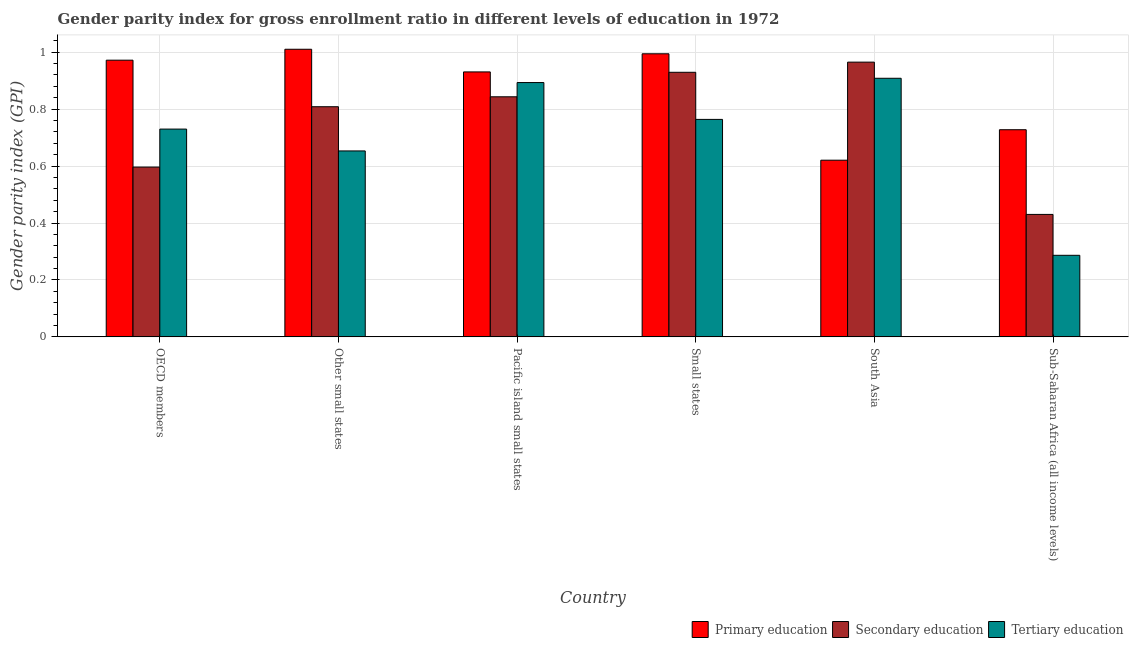Are the number of bars per tick equal to the number of legend labels?
Ensure brevity in your answer.  Yes. How many bars are there on the 3rd tick from the left?
Provide a succinct answer. 3. How many bars are there on the 6th tick from the right?
Offer a very short reply. 3. What is the label of the 1st group of bars from the left?
Offer a terse response. OECD members. What is the gender parity index in tertiary education in Other small states?
Provide a succinct answer. 0.65. Across all countries, what is the maximum gender parity index in tertiary education?
Your response must be concise. 0.91. Across all countries, what is the minimum gender parity index in secondary education?
Give a very brief answer. 0.43. In which country was the gender parity index in secondary education maximum?
Offer a very short reply. South Asia. What is the total gender parity index in secondary education in the graph?
Offer a very short reply. 4.57. What is the difference between the gender parity index in secondary education in OECD members and that in Other small states?
Give a very brief answer. -0.21. What is the difference between the gender parity index in tertiary education in Small states and the gender parity index in secondary education in Sub-Saharan Africa (all income levels)?
Your answer should be compact. 0.33. What is the average gender parity index in tertiary education per country?
Provide a short and direct response. 0.71. What is the difference between the gender parity index in secondary education and gender parity index in primary education in South Asia?
Offer a very short reply. 0.34. What is the ratio of the gender parity index in primary education in Other small states to that in Pacific island small states?
Offer a very short reply. 1.09. Is the gender parity index in secondary education in Other small states less than that in Sub-Saharan Africa (all income levels)?
Your response must be concise. No. Is the difference between the gender parity index in primary education in OECD members and Other small states greater than the difference between the gender parity index in tertiary education in OECD members and Other small states?
Give a very brief answer. No. What is the difference between the highest and the second highest gender parity index in primary education?
Offer a terse response. 0.02. What is the difference between the highest and the lowest gender parity index in tertiary education?
Give a very brief answer. 0.62. What does the 3rd bar from the left in Pacific island small states represents?
Provide a succinct answer. Tertiary education. What does the 1st bar from the right in OECD members represents?
Provide a succinct answer. Tertiary education. Are all the bars in the graph horizontal?
Give a very brief answer. No. What is the difference between two consecutive major ticks on the Y-axis?
Give a very brief answer. 0.2. Does the graph contain any zero values?
Provide a short and direct response. No. Does the graph contain grids?
Offer a very short reply. Yes. How are the legend labels stacked?
Make the answer very short. Horizontal. What is the title of the graph?
Give a very brief answer. Gender parity index for gross enrollment ratio in different levels of education in 1972. Does "Communicable diseases" appear as one of the legend labels in the graph?
Provide a short and direct response. No. What is the label or title of the X-axis?
Your answer should be very brief. Country. What is the label or title of the Y-axis?
Give a very brief answer. Gender parity index (GPI). What is the Gender parity index (GPI) of Primary education in OECD members?
Your answer should be very brief. 0.97. What is the Gender parity index (GPI) of Secondary education in OECD members?
Ensure brevity in your answer.  0.6. What is the Gender parity index (GPI) of Tertiary education in OECD members?
Provide a short and direct response. 0.73. What is the Gender parity index (GPI) of Primary education in Other small states?
Provide a succinct answer. 1.01. What is the Gender parity index (GPI) in Secondary education in Other small states?
Offer a very short reply. 0.81. What is the Gender parity index (GPI) of Tertiary education in Other small states?
Keep it short and to the point. 0.65. What is the Gender parity index (GPI) in Primary education in Pacific island small states?
Give a very brief answer. 0.93. What is the Gender parity index (GPI) of Secondary education in Pacific island small states?
Your response must be concise. 0.84. What is the Gender parity index (GPI) in Tertiary education in Pacific island small states?
Make the answer very short. 0.89. What is the Gender parity index (GPI) in Primary education in Small states?
Provide a short and direct response. 0.99. What is the Gender parity index (GPI) of Secondary education in Small states?
Offer a terse response. 0.93. What is the Gender parity index (GPI) of Tertiary education in Small states?
Provide a succinct answer. 0.76. What is the Gender parity index (GPI) in Primary education in South Asia?
Make the answer very short. 0.62. What is the Gender parity index (GPI) of Secondary education in South Asia?
Make the answer very short. 0.97. What is the Gender parity index (GPI) in Tertiary education in South Asia?
Provide a short and direct response. 0.91. What is the Gender parity index (GPI) in Primary education in Sub-Saharan Africa (all income levels)?
Provide a succinct answer. 0.73. What is the Gender parity index (GPI) of Secondary education in Sub-Saharan Africa (all income levels)?
Your response must be concise. 0.43. What is the Gender parity index (GPI) of Tertiary education in Sub-Saharan Africa (all income levels)?
Your answer should be compact. 0.29. Across all countries, what is the maximum Gender parity index (GPI) in Primary education?
Provide a succinct answer. 1.01. Across all countries, what is the maximum Gender parity index (GPI) in Secondary education?
Offer a terse response. 0.97. Across all countries, what is the maximum Gender parity index (GPI) in Tertiary education?
Your answer should be very brief. 0.91. Across all countries, what is the minimum Gender parity index (GPI) in Primary education?
Offer a terse response. 0.62. Across all countries, what is the minimum Gender parity index (GPI) in Secondary education?
Offer a very short reply. 0.43. Across all countries, what is the minimum Gender parity index (GPI) in Tertiary education?
Your response must be concise. 0.29. What is the total Gender parity index (GPI) of Primary education in the graph?
Offer a very short reply. 5.26. What is the total Gender parity index (GPI) in Secondary education in the graph?
Your answer should be compact. 4.57. What is the total Gender parity index (GPI) in Tertiary education in the graph?
Your answer should be very brief. 4.24. What is the difference between the Gender parity index (GPI) in Primary education in OECD members and that in Other small states?
Offer a very short reply. -0.04. What is the difference between the Gender parity index (GPI) in Secondary education in OECD members and that in Other small states?
Make the answer very short. -0.21. What is the difference between the Gender parity index (GPI) of Tertiary education in OECD members and that in Other small states?
Offer a terse response. 0.08. What is the difference between the Gender parity index (GPI) in Primary education in OECD members and that in Pacific island small states?
Make the answer very short. 0.04. What is the difference between the Gender parity index (GPI) of Secondary education in OECD members and that in Pacific island small states?
Ensure brevity in your answer.  -0.25. What is the difference between the Gender parity index (GPI) in Tertiary education in OECD members and that in Pacific island small states?
Offer a very short reply. -0.16. What is the difference between the Gender parity index (GPI) of Primary education in OECD members and that in Small states?
Ensure brevity in your answer.  -0.02. What is the difference between the Gender parity index (GPI) in Secondary education in OECD members and that in Small states?
Ensure brevity in your answer.  -0.33. What is the difference between the Gender parity index (GPI) in Tertiary education in OECD members and that in Small states?
Give a very brief answer. -0.03. What is the difference between the Gender parity index (GPI) in Primary education in OECD members and that in South Asia?
Offer a very short reply. 0.35. What is the difference between the Gender parity index (GPI) of Secondary education in OECD members and that in South Asia?
Give a very brief answer. -0.37. What is the difference between the Gender parity index (GPI) of Tertiary education in OECD members and that in South Asia?
Provide a short and direct response. -0.18. What is the difference between the Gender parity index (GPI) in Primary education in OECD members and that in Sub-Saharan Africa (all income levels)?
Your answer should be very brief. 0.24. What is the difference between the Gender parity index (GPI) in Secondary education in OECD members and that in Sub-Saharan Africa (all income levels)?
Keep it short and to the point. 0.17. What is the difference between the Gender parity index (GPI) in Tertiary education in OECD members and that in Sub-Saharan Africa (all income levels)?
Make the answer very short. 0.44. What is the difference between the Gender parity index (GPI) in Primary education in Other small states and that in Pacific island small states?
Make the answer very short. 0.08. What is the difference between the Gender parity index (GPI) in Secondary education in Other small states and that in Pacific island small states?
Your answer should be very brief. -0.03. What is the difference between the Gender parity index (GPI) in Tertiary education in Other small states and that in Pacific island small states?
Your answer should be very brief. -0.24. What is the difference between the Gender parity index (GPI) of Primary education in Other small states and that in Small states?
Offer a very short reply. 0.02. What is the difference between the Gender parity index (GPI) of Secondary education in Other small states and that in Small states?
Keep it short and to the point. -0.12. What is the difference between the Gender parity index (GPI) of Tertiary education in Other small states and that in Small states?
Provide a short and direct response. -0.11. What is the difference between the Gender parity index (GPI) in Primary education in Other small states and that in South Asia?
Provide a succinct answer. 0.39. What is the difference between the Gender parity index (GPI) in Secondary education in Other small states and that in South Asia?
Offer a terse response. -0.16. What is the difference between the Gender parity index (GPI) in Tertiary education in Other small states and that in South Asia?
Provide a succinct answer. -0.26. What is the difference between the Gender parity index (GPI) of Primary education in Other small states and that in Sub-Saharan Africa (all income levels)?
Your response must be concise. 0.28. What is the difference between the Gender parity index (GPI) of Secondary education in Other small states and that in Sub-Saharan Africa (all income levels)?
Offer a very short reply. 0.38. What is the difference between the Gender parity index (GPI) of Tertiary education in Other small states and that in Sub-Saharan Africa (all income levels)?
Make the answer very short. 0.37. What is the difference between the Gender parity index (GPI) of Primary education in Pacific island small states and that in Small states?
Your answer should be very brief. -0.06. What is the difference between the Gender parity index (GPI) of Secondary education in Pacific island small states and that in Small states?
Provide a short and direct response. -0.09. What is the difference between the Gender parity index (GPI) in Tertiary education in Pacific island small states and that in Small states?
Keep it short and to the point. 0.13. What is the difference between the Gender parity index (GPI) of Primary education in Pacific island small states and that in South Asia?
Your answer should be very brief. 0.31. What is the difference between the Gender parity index (GPI) of Secondary education in Pacific island small states and that in South Asia?
Make the answer very short. -0.12. What is the difference between the Gender parity index (GPI) of Tertiary education in Pacific island small states and that in South Asia?
Your response must be concise. -0.02. What is the difference between the Gender parity index (GPI) in Primary education in Pacific island small states and that in Sub-Saharan Africa (all income levels)?
Provide a succinct answer. 0.2. What is the difference between the Gender parity index (GPI) of Secondary education in Pacific island small states and that in Sub-Saharan Africa (all income levels)?
Offer a terse response. 0.41. What is the difference between the Gender parity index (GPI) of Tertiary education in Pacific island small states and that in Sub-Saharan Africa (all income levels)?
Provide a succinct answer. 0.61. What is the difference between the Gender parity index (GPI) in Primary education in Small states and that in South Asia?
Your answer should be compact. 0.37. What is the difference between the Gender parity index (GPI) of Secondary education in Small states and that in South Asia?
Your response must be concise. -0.04. What is the difference between the Gender parity index (GPI) in Tertiary education in Small states and that in South Asia?
Provide a short and direct response. -0.14. What is the difference between the Gender parity index (GPI) of Primary education in Small states and that in Sub-Saharan Africa (all income levels)?
Ensure brevity in your answer.  0.27. What is the difference between the Gender parity index (GPI) in Secondary education in Small states and that in Sub-Saharan Africa (all income levels)?
Offer a very short reply. 0.5. What is the difference between the Gender parity index (GPI) in Tertiary education in Small states and that in Sub-Saharan Africa (all income levels)?
Keep it short and to the point. 0.48. What is the difference between the Gender parity index (GPI) in Primary education in South Asia and that in Sub-Saharan Africa (all income levels)?
Keep it short and to the point. -0.11. What is the difference between the Gender parity index (GPI) in Secondary education in South Asia and that in Sub-Saharan Africa (all income levels)?
Ensure brevity in your answer.  0.54. What is the difference between the Gender parity index (GPI) in Tertiary education in South Asia and that in Sub-Saharan Africa (all income levels)?
Keep it short and to the point. 0.62. What is the difference between the Gender parity index (GPI) in Primary education in OECD members and the Gender parity index (GPI) in Secondary education in Other small states?
Provide a short and direct response. 0.16. What is the difference between the Gender parity index (GPI) in Primary education in OECD members and the Gender parity index (GPI) in Tertiary education in Other small states?
Make the answer very short. 0.32. What is the difference between the Gender parity index (GPI) of Secondary education in OECD members and the Gender parity index (GPI) of Tertiary education in Other small states?
Your answer should be compact. -0.06. What is the difference between the Gender parity index (GPI) of Primary education in OECD members and the Gender parity index (GPI) of Secondary education in Pacific island small states?
Make the answer very short. 0.13. What is the difference between the Gender parity index (GPI) in Primary education in OECD members and the Gender parity index (GPI) in Tertiary education in Pacific island small states?
Give a very brief answer. 0.08. What is the difference between the Gender parity index (GPI) in Secondary education in OECD members and the Gender parity index (GPI) in Tertiary education in Pacific island small states?
Your answer should be very brief. -0.3. What is the difference between the Gender parity index (GPI) in Primary education in OECD members and the Gender parity index (GPI) in Secondary education in Small states?
Make the answer very short. 0.04. What is the difference between the Gender parity index (GPI) in Primary education in OECD members and the Gender parity index (GPI) in Tertiary education in Small states?
Your answer should be compact. 0.21. What is the difference between the Gender parity index (GPI) of Secondary education in OECD members and the Gender parity index (GPI) of Tertiary education in Small states?
Your answer should be compact. -0.17. What is the difference between the Gender parity index (GPI) in Primary education in OECD members and the Gender parity index (GPI) in Secondary education in South Asia?
Your response must be concise. 0.01. What is the difference between the Gender parity index (GPI) of Primary education in OECD members and the Gender parity index (GPI) of Tertiary education in South Asia?
Make the answer very short. 0.06. What is the difference between the Gender parity index (GPI) of Secondary education in OECD members and the Gender parity index (GPI) of Tertiary education in South Asia?
Your answer should be compact. -0.31. What is the difference between the Gender parity index (GPI) of Primary education in OECD members and the Gender parity index (GPI) of Secondary education in Sub-Saharan Africa (all income levels)?
Ensure brevity in your answer.  0.54. What is the difference between the Gender parity index (GPI) in Primary education in OECD members and the Gender parity index (GPI) in Tertiary education in Sub-Saharan Africa (all income levels)?
Provide a succinct answer. 0.69. What is the difference between the Gender parity index (GPI) of Secondary education in OECD members and the Gender parity index (GPI) of Tertiary education in Sub-Saharan Africa (all income levels)?
Your answer should be compact. 0.31. What is the difference between the Gender parity index (GPI) of Primary education in Other small states and the Gender parity index (GPI) of Secondary education in Pacific island small states?
Offer a terse response. 0.17. What is the difference between the Gender parity index (GPI) in Primary education in Other small states and the Gender parity index (GPI) in Tertiary education in Pacific island small states?
Your answer should be compact. 0.12. What is the difference between the Gender parity index (GPI) of Secondary education in Other small states and the Gender parity index (GPI) of Tertiary education in Pacific island small states?
Provide a succinct answer. -0.08. What is the difference between the Gender parity index (GPI) of Primary education in Other small states and the Gender parity index (GPI) of Secondary education in Small states?
Offer a very short reply. 0.08. What is the difference between the Gender parity index (GPI) in Primary education in Other small states and the Gender parity index (GPI) in Tertiary education in Small states?
Give a very brief answer. 0.25. What is the difference between the Gender parity index (GPI) in Secondary education in Other small states and the Gender parity index (GPI) in Tertiary education in Small states?
Your response must be concise. 0.04. What is the difference between the Gender parity index (GPI) of Primary education in Other small states and the Gender parity index (GPI) of Secondary education in South Asia?
Offer a terse response. 0.05. What is the difference between the Gender parity index (GPI) in Primary education in Other small states and the Gender parity index (GPI) in Tertiary education in South Asia?
Your answer should be very brief. 0.1. What is the difference between the Gender parity index (GPI) of Secondary education in Other small states and the Gender parity index (GPI) of Tertiary education in South Asia?
Provide a short and direct response. -0.1. What is the difference between the Gender parity index (GPI) of Primary education in Other small states and the Gender parity index (GPI) of Secondary education in Sub-Saharan Africa (all income levels)?
Your response must be concise. 0.58. What is the difference between the Gender parity index (GPI) in Primary education in Other small states and the Gender parity index (GPI) in Tertiary education in Sub-Saharan Africa (all income levels)?
Give a very brief answer. 0.72. What is the difference between the Gender parity index (GPI) of Secondary education in Other small states and the Gender parity index (GPI) of Tertiary education in Sub-Saharan Africa (all income levels)?
Provide a short and direct response. 0.52. What is the difference between the Gender parity index (GPI) of Primary education in Pacific island small states and the Gender parity index (GPI) of Secondary education in Small states?
Your answer should be compact. 0. What is the difference between the Gender parity index (GPI) of Primary education in Pacific island small states and the Gender parity index (GPI) of Tertiary education in Small states?
Your answer should be compact. 0.17. What is the difference between the Gender parity index (GPI) in Secondary education in Pacific island small states and the Gender parity index (GPI) in Tertiary education in Small states?
Your response must be concise. 0.08. What is the difference between the Gender parity index (GPI) of Primary education in Pacific island small states and the Gender parity index (GPI) of Secondary education in South Asia?
Offer a terse response. -0.03. What is the difference between the Gender parity index (GPI) of Primary education in Pacific island small states and the Gender parity index (GPI) of Tertiary education in South Asia?
Offer a very short reply. 0.02. What is the difference between the Gender parity index (GPI) in Secondary education in Pacific island small states and the Gender parity index (GPI) in Tertiary education in South Asia?
Give a very brief answer. -0.07. What is the difference between the Gender parity index (GPI) in Primary education in Pacific island small states and the Gender parity index (GPI) in Secondary education in Sub-Saharan Africa (all income levels)?
Ensure brevity in your answer.  0.5. What is the difference between the Gender parity index (GPI) of Primary education in Pacific island small states and the Gender parity index (GPI) of Tertiary education in Sub-Saharan Africa (all income levels)?
Ensure brevity in your answer.  0.64. What is the difference between the Gender parity index (GPI) of Secondary education in Pacific island small states and the Gender parity index (GPI) of Tertiary education in Sub-Saharan Africa (all income levels)?
Your answer should be compact. 0.56. What is the difference between the Gender parity index (GPI) in Primary education in Small states and the Gender parity index (GPI) in Secondary education in South Asia?
Give a very brief answer. 0.03. What is the difference between the Gender parity index (GPI) in Primary education in Small states and the Gender parity index (GPI) in Tertiary education in South Asia?
Your answer should be compact. 0.09. What is the difference between the Gender parity index (GPI) of Secondary education in Small states and the Gender parity index (GPI) of Tertiary education in South Asia?
Provide a short and direct response. 0.02. What is the difference between the Gender parity index (GPI) in Primary education in Small states and the Gender parity index (GPI) in Secondary education in Sub-Saharan Africa (all income levels)?
Make the answer very short. 0.56. What is the difference between the Gender parity index (GPI) in Primary education in Small states and the Gender parity index (GPI) in Tertiary education in Sub-Saharan Africa (all income levels)?
Your answer should be compact. 0.71. What is the difference between the Gender parity index (GPI) of Secondary education in Small states and the Gender parity index (GPI) of Tertiary education in Sub-Saharan Africa (all income levels)?
Make the answer very short. 0.64. What is the difference between the Gender parity index (GPI) of Primary education in South Asia and the Gender parity index (GPI) of Secondary education in Sub-Saharan Africa (all income levels)?
Ensure brevity in your answer.  0.19. What is the difference between the Gender parity index (GPI) of Primary education in South Asia and the Gender parity index (GPI) of Tertiary education in Sub-Saharan Africa (all income levels)?
Give a very brief answer. 0.33. What is the difference between the Gender parity index (GPI) in Secondary education in South Asia and the Gender parity index (GPI) in Tertiary education in Sub-Saharan Africa (all income levels)?
Offer a terse response. 0.68. What is the average Gender parity index (GPI) of Primary education per country?
Provide a short and direct response. 0.88. What is the average Gender parity index (GPI) of Secondary education per country?
Offer a terse response. 0.76. What is the average Gender parity index (GPI) in Tertiary education per country?
Ensure brevity in your answer.  0.71. What is the difference between the Gender parity index (GPI) of Primary education and Gender parity index (GPI) of Secondary education in OECD members?
Give a very brief answer. 0.38. What is the difference between the Gender parity index (GPI) in Primary education and Gender parity index (GPI) in Tertiary education in OECD members?
Your response must be concise. 0.24. What is the difference between the Gender parity index (GPI) of Secondary education and Gender parity index (GPI) of Tertiary education in OECD members?
Give a very brief answer. -0.13. What is the difference between the Gender parity index (GPI) of Primary education and Gender parity index (GPI) of Secondary education in Other small states?
Offer a very short reply. 0.2. What is the difference between the Gender parity index (GPI) in Primary education and Gender parity index (GPI) in Tertiary education in Other small states?
Offer a very short reply. 0.36. What is the difference between the Gender parity index (GPI) of Secondary education and Gender parity index (GPI) of Tertiary education in Other small states?
Keep it short and to the point. 0.16. What is the difference between the Gender parity index (GPI) in Primary education and Gender parity index (GPI) in Secondary education in Pacific island small states?
Give a very brief answer. 0.09. What is the difference between the Gender parity index (GPI) of Primary education and Gender parity index (GPI) of Tertiary education in Pacific island small states?
Provide a succinct answer. 0.04. What is the difference between the Gender parity index (GPI) of Secondary education and Gender parity index (GPI) of Tertiary education in Pacific island small states?
Offer a very short reply. -0.05. What is the difference between the Gender parity index (GPI) of Primary education and Gender parity index (GPI) of Secondary education in Small states?
Keep it short and to the point. 0.07. What is the difference between the Gender parity index (GPI) in Primary education and Gender parity index (GPI) in Tertiary education in Small states?
Make the answer very short. 0.23. What is the difference between the Gender parity index (GPI) of Secondary education and Gender parity index (GPI) of Tertiary education in Small states?
Make the answer very short. 0.17. What is the difference between the Gender parity index (GPI) in Primary education and Gender parity index (GPI) in Secondary education in South Asia?
Your response must be concise. -0.34. What is the difference between the Gender parity index (GPI) of Primary education and Gender parity index (GPI) of Tertiary education in South Asia?
Your answer should be compact. -0.29. What is the difference between the Gender parity index (GPI) of Secondary education and Gender parity index (GPI) of Tertiary education in South Asia?
Give a very brief answer. 0.06. What is the difference between the Gender parity index (GPI) in Primary education and Gender parity index (GPI) in Secondary education in Sub-Saharan Africa (all income levels)?
Offer a terse response. 0.3. What is the difference between the Gender parity index (GPI) of Primary education and Gender parity index (GPI) of Tertiary education in Sub-Saharan Africa (all income levels)?
Your answer should be compact. 0.44. What is the difference between the Gender parity index (GPI) of Secondary education and Gender parity index (GPI) of Tertiary education in Sub-Saharan Africa (all income levels)?
Provide a short and direct response. 0.14. What is the ratio of the Gender parity index (GPI) in Secondary education in OECD members to that in Other small states?
Make the answer very short. 0.74. What is the ratio of the Gender parity index (GPI) in Tertiary education in OECD members to that in Other small states?
Your answer should be very brief. 1.12. What is the ratio of the Gender parity index (GPI) in Primary education in OECD members to that in Pacific island small states?
Offer a terse response. 1.04. What is the ratio of the Gender parity index (GPI) in Secondary education in OECD members to that in Pacific island small states?
Give a very brief answer. 0.71. What is the ratio of the Gender parity index (GPI) in Tertiary education in OECD members to that in Pacific island small states?
Ensure brevity in your answer.  0.82. What is the ratio of the Gender parity index (GPI) in Primary education in OECD members to that in Small states?
Offer a very short reply. 0.98. What is the ratio of the Gender parity index (GPI) of Secondary education in OECD members to that in Small states?
Provide a succinct answer. 0.64. What is the ratio of the Gender parity index (GPI) of Tertiary education in OECD members to that in Small states?
Give a very brief answer. 0.96. What is the ratio of the Gender parity index (GPI) in Primary education in OECD members to that in South Asia?
Make the answer very short. 1.57. What is the ratio of the Gender parity index (GPI) of Secondary education in OECD members to that in South Asia?
Make the answer very short. 0.62. What is the ratio of the Gender parity index (GPI) in Tertiary education in OECD members to that in South Asia?
Make the answer very short. 0.8. What is the ratio of the Gender parity index (GPI) of Primary education in OECD members to that in Sub-Saharan Africa (all income levels)?
Your response must be concise. 1.34. What is the ratio of the Gender parity index (GPI) in Secondary education in OECD members to that in Sub-Saharan Africa (all income levels)?
Your answer should be compact. 1.39. What is the ratio of the Gender parity index (GPI) in Tertiary education in OECD members to that in Sub-Saharan Africa (all income levels)?
Ensure brevity in your answer.  2.55. What is the ratio of the Gender parity index (GPI) of Primary education in Other small states to that in Pacific island small states?
Your response must be concise. 1.09. What is the ratio of the Gender parity index (GPI) of Secondary education in Other small states to that in Pacific island small states?
Provide a succinct answer. 0.96. What is the ratio of the Gender parity index (GPI) of Tertiary education in Other small states to that in Pacific island small states?
Your answer should be compact. 0.73. What is the ratio of the Gender parity index (GPI) in Secondary education in Other small states to that in Small states?
Your answer should be very brief. 0.87. What is the ratio of the Gender parity index (GPI) in Tertiary education in Other small states to that in Small states?
Your response must be concise. 0.85. What is the ratio of the Gender parity index (GPI) of Primary education in Other small states to that in South Asia?
Keep it short and to the point. 1.63. What is the ratio of the Gender parity index (GPI) in Secondary education in Other small states to that in South Asia?
Ensure brevity in your answer.  0.84. What is the ratio of the Gender parity index (GPI) in Tertiary education in Other small states to that in South Asia?
Provide a short and direct response. 0.72. What is the ratio of the Gender parity index (GPI) in Primary education in Other small states to that in Sub-Saharan Africa (all income levels)?
Your answer should be very brief. 1.39. What is the ratio of the Gender parity index (GPI) of Secondary education in Other small states to that in Sub-Saharan Africa (all income levels)?
Your answer should be compact. 1.88. What is the ratio of the Gender parity index (GPI) in Tertiary education in Other small states to that in Sub-Saharan Africa (all income levels)?
Your answer should be very brief. 2.28. What is the ratio of the Gender parity index (GPI) of Primary education in Pacific island small states to that in Small states?
Your response must be concise. 0.94. What is the ratio of the Gender parity index (GPI) of Secondary education in Pacific island small states to that in Small states?
Provide a succinct answer. 0.91. What is the ratio of the Gender parity index (GPI) in Tertiary education in Pacific island small states to that in Small states?
Your answer should be compact. 1.17. What is the ratio of the Gender parity index (GPI) of Primary education in Pacific island small states to that in South Asia?
Ensure brevity in your answer.  1.5. What is the ratio of the Gender parity index (GPI) of Secondary education in Pacific island small states to that in South Asia?
Your answer should be very brief. 0.87. What is the ratio of the Gender parity index (GPI) in Tertiary education in Pacific island small states to that in South Asia?
Ensure brevity in your answer.  0.98. What is the ratio of the Gender parity index (GPI) in Primary education in Pacific island small states to that in Sub-Saharan Africa (all income levels)?
Ensure brevity in your answer.  1.28. What is the ratio of the Gender parity index (GPI) of Secondary education in Pacific island small states to that in Sub-Saharan Africa (all income levels)?
Give a very brief answer. 1.96. What is the ratio of the Gender parity index (GPI) in Tertiary education in Pacific island small states to that in Sub-Saharan Africa (all income levels)?
Make the answer very short. 3.12. What is the ratio of the Gender parity index (GPI) in Primary education in Small states to that in South Asia?
Provide a short and direct response. 1.6. What is the ratio of the Gender parity index (GPI) in Tertiary education in Small states to that in South Asia?
Provide a short and direct response. 0.84. What is the ratio of the Gender parity index (GPI) in Primary education in Small states to that in Sub-Saharan Africa (all income levels)?
Your answer should be compact. 1.37. What is the ratio of the Gender parity index (GPI) in Secondary education in Small states to that in Sub-Saharan Africa (all income levels)?
Keep it short and to the point. 2.16. What is the ratio of the Gender parity index (GPI) of Tertiary education in Small states to that in Sub-Saharan Africa (all income levels)?
Your answer should be very brief. 2.67. What is the ratio of the Gender parity index (GPI) in Primary education in South Asia to that in Sub-Saharan Africa (all income levels)?
Your answer should be very brief. 0.85. What is the ratio of the Gender parity index (GPI) in Secondary education in South Asia to that in Sub-Saharan Africa (all income levels)?
Make the answer very short. 2.24. What is the ratio of the Gender parity index (GPI) of Tertiary education in South Asia to that in Sub-Saharan Africa (all income levels)?
Ensure brevity in your answer.  3.17. What is the difference between the highest and the second highest Gender parity index (GPI) of Primary education?
Your answer should be compact. 0.02. What is the difference between the highest and the second highest Gender parity index (GPI) of Secondary education?
Keep it short and to the point. 0.04. What is the difference between the highest and the second highest Gender parity index (GPI) of Tertiary education?
Keep it short and to the point. 0.02. What is the difference between the highest and the lowest Gender parity index (GPI) of Primary education?
Keep it short and to the point. 0.39. What is the difference between the highest and the lowest Gender parity index (GPI) in Secondary education?
Your answer should be compact. 0.54. What is the difference between the highest and the lowest Gender parity index (GPI) of Tertiary education?
Provide a short and direct response. 0.62. 